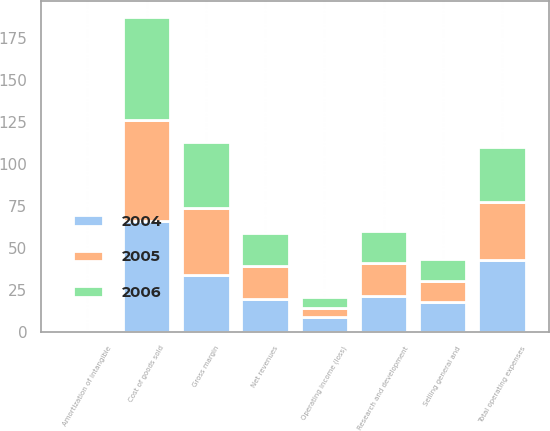Convert chart to OTSL. <chart><loc_0><loc_0><loc_500><loc_500><stacked_bar_chart><ecel><fcel>Net revenues<fcel>Cost of goods sold<fcel>Gross margin<fcel>Research and development<fcel>Selling general and<fcel>Amortization of intangible<fcel>Total operating expenses<fcel>Operating income (loss)<nl><fcel>2004<fcel>19.5<fcel>66.1<fcel>33.9<fcel>21.2<fcel>17.6<fcel>0.3<fcel>42.6<fcel>8.7<nl><fcel>2006<fcel>19.5<fcel>61.2<fcel>38.8<fcel>19.2<fcel>13<fcel>0.3<fcel>32.5<fcel>6.3<nl><fcel>2005<fcel>19.5<fcel>60.1<fcel>39.9<fcel>19.5<fcel>12.4<fcel>0.4<fcel>34.5<fcel>5.4<nl></chart> 